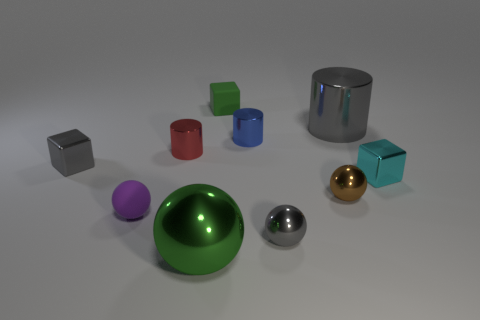Subtract all cubes. How many objects are left? 7 Subtract 1 cubes. How many cubes are left? 2 Subtract all purple cylinders. Subtract all yellow blocks. How many cylinders are left? 3 Subtract all red cylinders. How many green cubes are left? 1 Subtract all big yellow rubber cylinders. Subtract all cubes. How many objects are left? 7 Add 2 large shiny cylinders. How many large shiny cylinders are left? 3 Add 6 cyan objects. How many cyan objects exist? 7 Subtract all purple spheres. How many spheres are left? 3 Subtract all tiny cyan shiny cubes. How many cubes are left? 2 Subtract 1 blue cylinders. How many objects are left? 9 